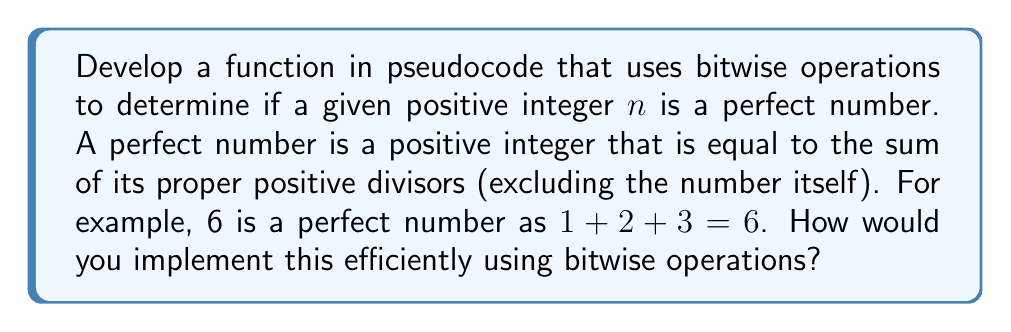Could you help me with this problem? To solve this problem efficiently using bitwise operations, we can follow these steps:

1. Initialize a variable $sum = 1$ to store the sum of proper divisors.

2. Iterate from $i = 2$ to $\sqrt{n}$:
   a. If $n \& (1 << (i-1)) \neq 0$, then $i$ is a divisor of $n$.
   b. If $i$ is a divisor, add $i$ and $n/i$ to $sum$.

3. Check if $sum == n$.

Here's the pseudocode implementation:

```
function isPerfectNumber(n):
    if n <= 1:
        return false
    
    sum = 1
    i = 2
    while i * i <= n:
        if (n & (1 << (i - 1))) != 0:
            sum += i
            if i * i != n:
                sum += n / i
        i++
    
    return sum == n
```

Explanation of bitwise operation:
- $(1 << (i - 1))$ creates a bitmask with only the $i$-th bit set to 1.
- $n \& (1 << (i - 1))$ performs a bitwise AND operation between $n$ and the bitmask.
- If the result is non-zero, it means $i$ is a divisor of $n$.

This approach is more efficient than testing divisibility using modulo operations, as bitwise operations are generally faster. The time complexity is $O(\sqrt{n})$, which is optimal for this problem.

Note: This method works efficiently for numbers up to 32 bits (for 64-bit integers, slight modifications would be needed).
Answer: Pseudocode function using bitwise AND to check divisors and sum them efficiently. 